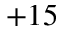<formula> <loc_0><loc_0><loc_500><loc_500>+ 1 5</formula> 